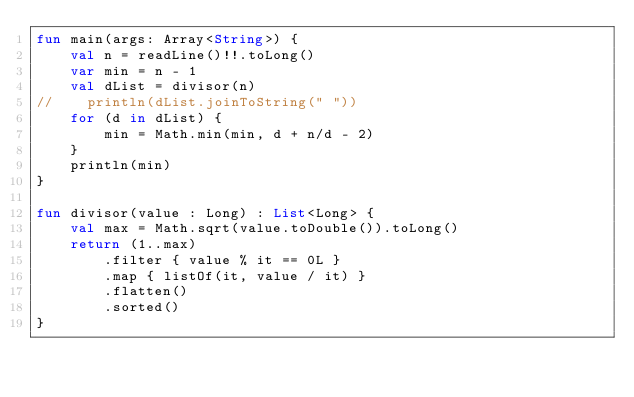<code> <loc_0><loc_0><loc_500><loc_500><_Kotlin_>fun main(args: Array<String>) {
    val n = readLine()!!.toLong()
    var min = n - 1
    val dList = divisor(n)
//    println(dList.joinToString(" "))
    for (d in dList) {
        min = Math.min(min, d + n/d - 2)
    }
    println(min)
}

fun divisor(value : Long) : List<Long> {
    val max = Math.sqrt(value.toDouble()).toLong()
    return (1..max)
        .filter { value % it == 0L }
        .map { listOf(it, value / it) }
        .flatten()
        .sorted()
}</code> 